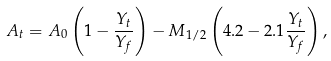<formula> <loc_0><loc_0><loc_500><loc_500>A _ { t } = A _ { 0 } \left ( 1 - \frac { Y _ { t } } { Y _ { f } } \right ) - M _ { 1 / 2 } \left ( 4 . 2 - 2 . 1 \frac { Y _ { t } } { Y _ { f } } \right ) ,</formula> 